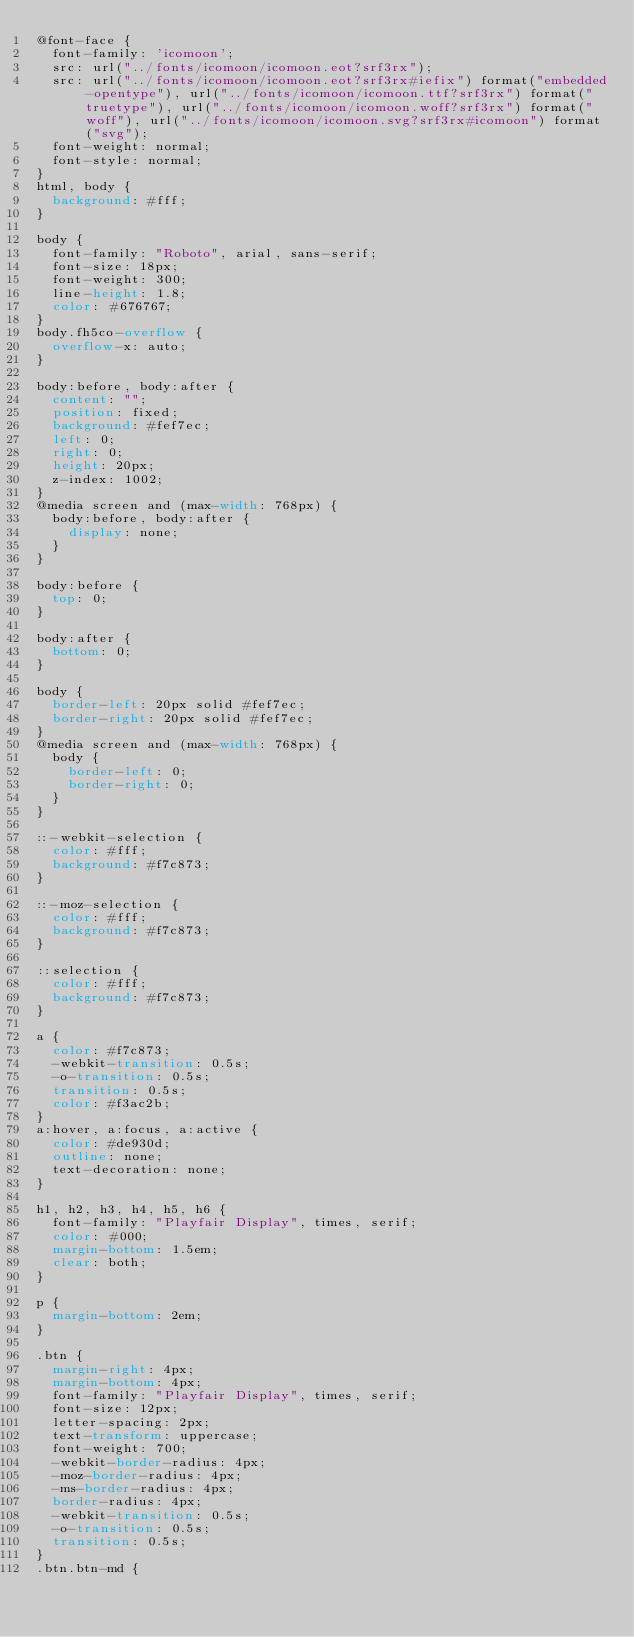<code> <loc_0><loc_0><loc_500><loc_500><_CSS_>@font-face {
  font-family: 'icomoon';
  src: url("../fonts/icomoon/icomoon.eot?srf3rx");
  src: url("../fonts/icomoon/icomoon.eot?srf3rx#iefix") format("embedded-opentype"), url("../fonts/icomoon/icomoon.ttf?srf3rx") format("truetype"), url("../fonts/icomoon/icomoon.woff?srf3rx") format("woff"), url("../fonts/icomoon/icomoon.svg?srf3rx#icomoon") format("svg");
  font-weight: normal;
  font-style: normal;
}
html, body {
  background: #fff;
}

body {
  font-family: "Roboto", arial, sans-serif;
  font-size: 18px;
  font-weight: 300;
  line-height: 1.8;
  color: #676767;
}
body.fh5co-overflow {
  overflow-x: auto;
}

body:before, body:after {
  content: "";
  position: fixed;
  background: #fef7ec;
  left: 0;
  right: 0;
  height: 20px;
  z-index: 1002;
}
@media screen and (max-width: 768px) {
  body:before, body:after {
    display: none;
  }
}

body:before {
  top: 0;
}

body:after {
  bottom: 0;
}

body {
  border-left: 20px solid #fef7ec;
  border-right: 20px solid #fef7ec;
}
@media screen and (max-width: 768px) {
  body {
    border-left: 0;
    border-right: 0;
  }
}

::-webkit-selection {
  color: #fff;
  background: #f7c873;
}

::-moz-selection {
  color: #fff;
  background: #f7c873;
}

::selection {
  color: #fff;
  background: #f7c873;
}

a {
  color: #f7c873;
  -webkit-transition: 0.5s;
  -o-transition: 0.5s;
  transition: 0.5s;
  color: #f3ac2b;
}
a:hover, a:focus, a:active {
  color: #de930d;
  outline: none;
  text-decoration: none;
}

h1, h2, h3, h4, h5, h6 {
  font-family: "Playfair Display", times, serif;
  color: #000;
  margin-bottom: 1.5em;
  clear: both;
}

p {
  margin-bottom: 2em;
}

.btn {
  margin-right: 4px;
  margin-bottom: 4px;
  font-family: "Playfair Display", times, serif;
  font-size: 12px;
  letter-spacing: 2px;
  text-transform: uppercase;
  font-weight: 700;
  -webkit-border-radius: 4px;
  -moz-border-radius: 4px;
  -ms-border-radius: 4px;
  border-radius: 4px;
  -webkit-transition: 0.5s;
  -o-transition: 0.5s;
  transition: 0.5s;
}
.btn.btn-md {</code> 